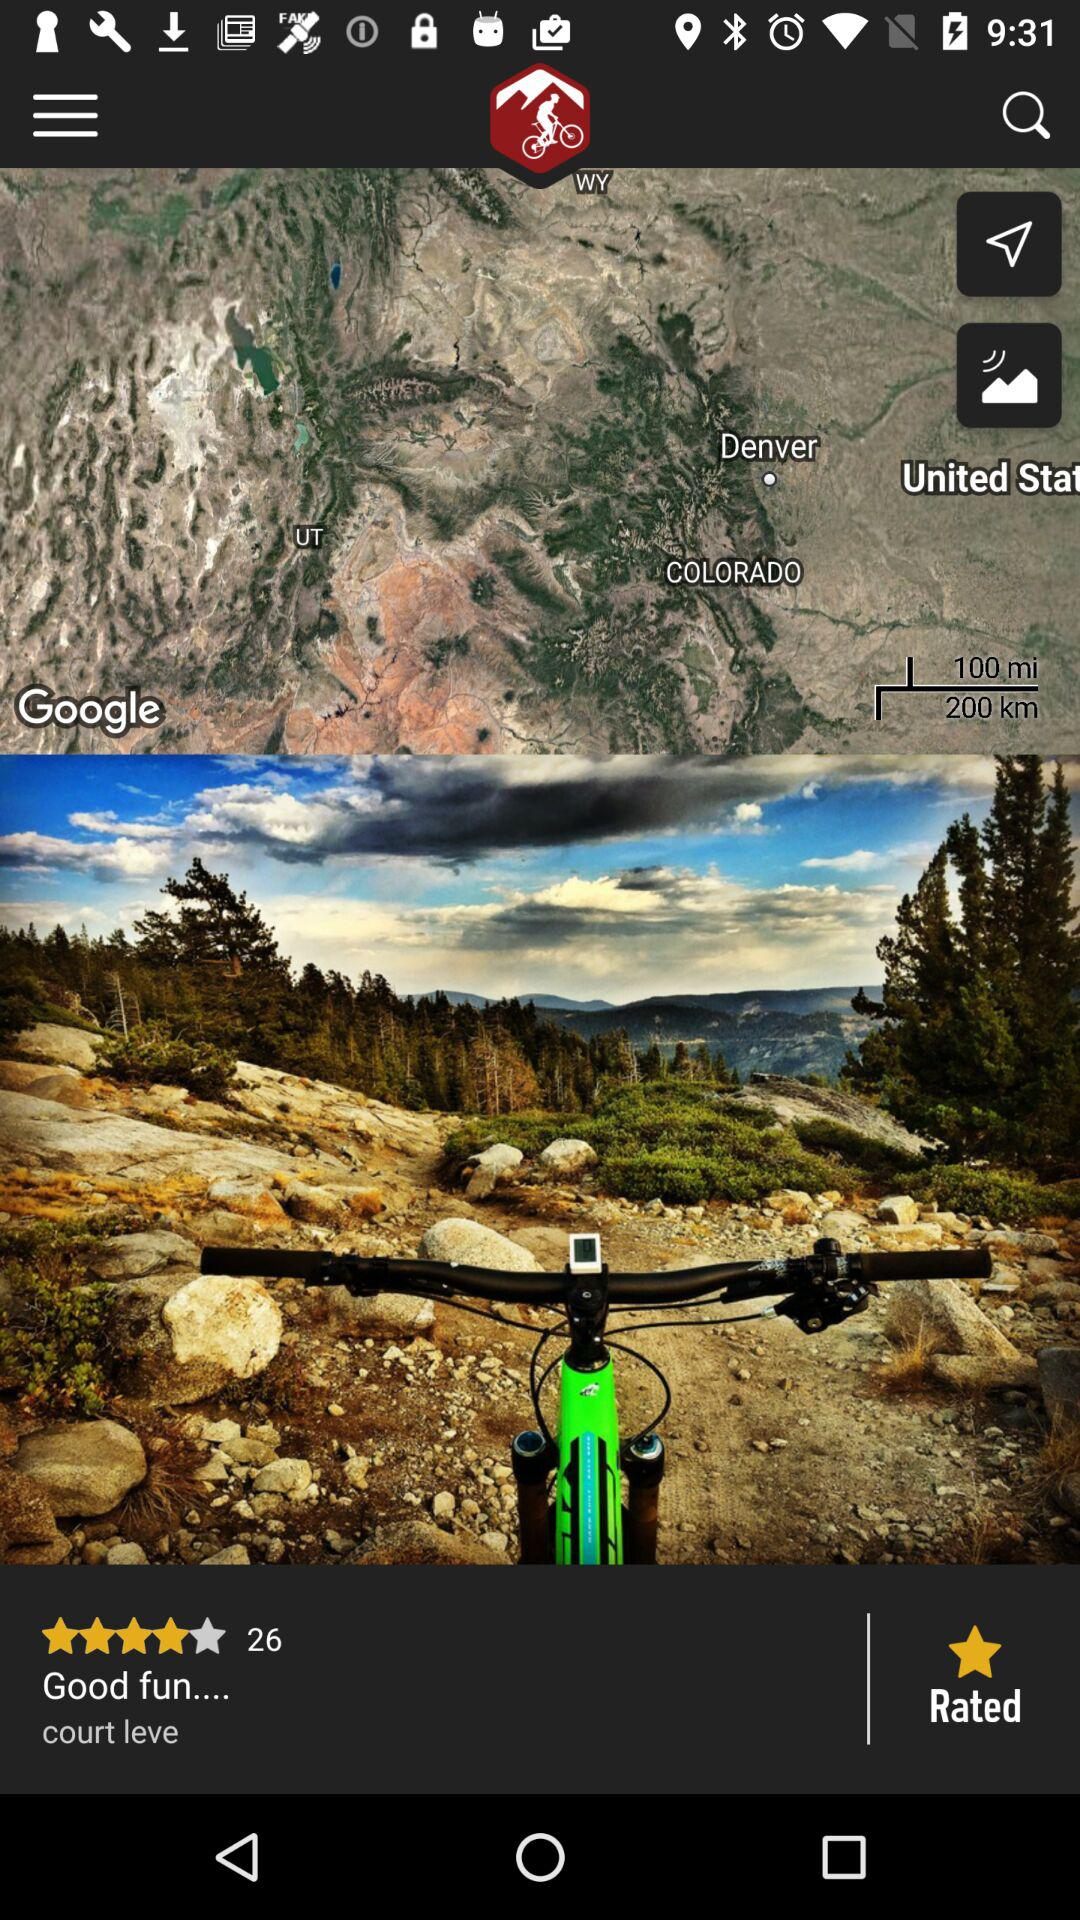What is the name of the application?
When the provided information is insufficient, respond with <no answer>. <no answer> 